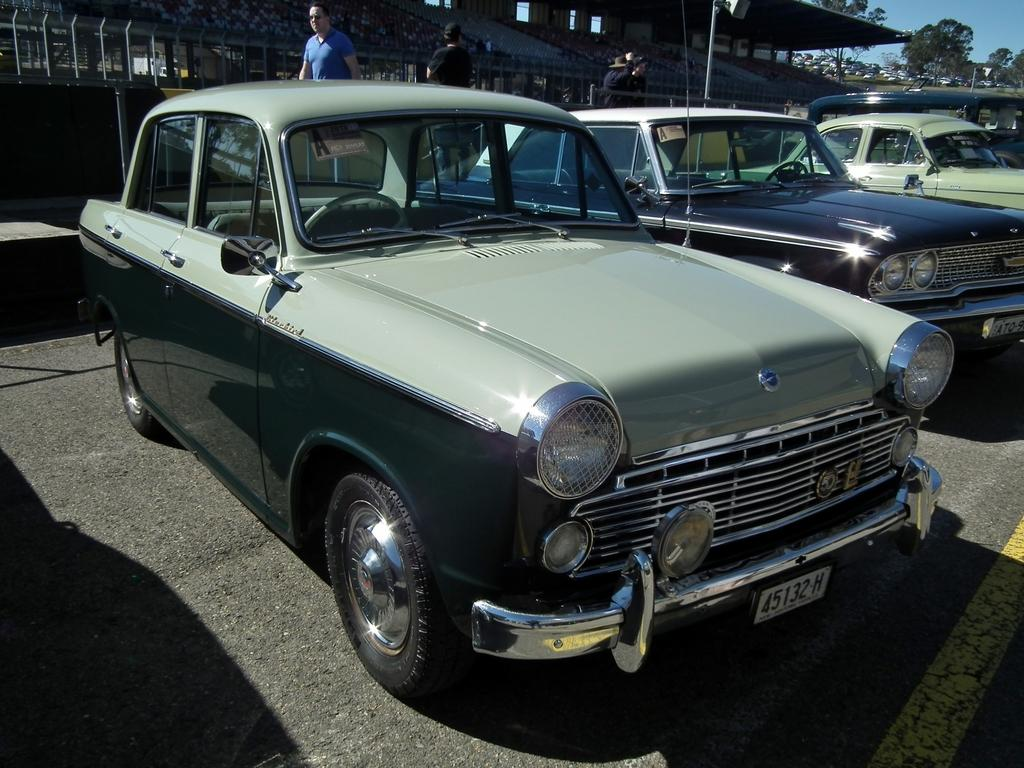What can be seen on the road in the image? There are cars parked on the road in the image. What are people doing in the background of the image? People are walking on the sidewalk in the background of the image. What is visible behind the parked cars and people walking? There is a fence, buildings, trees, and the sky visible in the background of the image. What type of steel is used to make the key visible in the image? There is no key present in the image, so it is not possible to determine the type of steel used. 